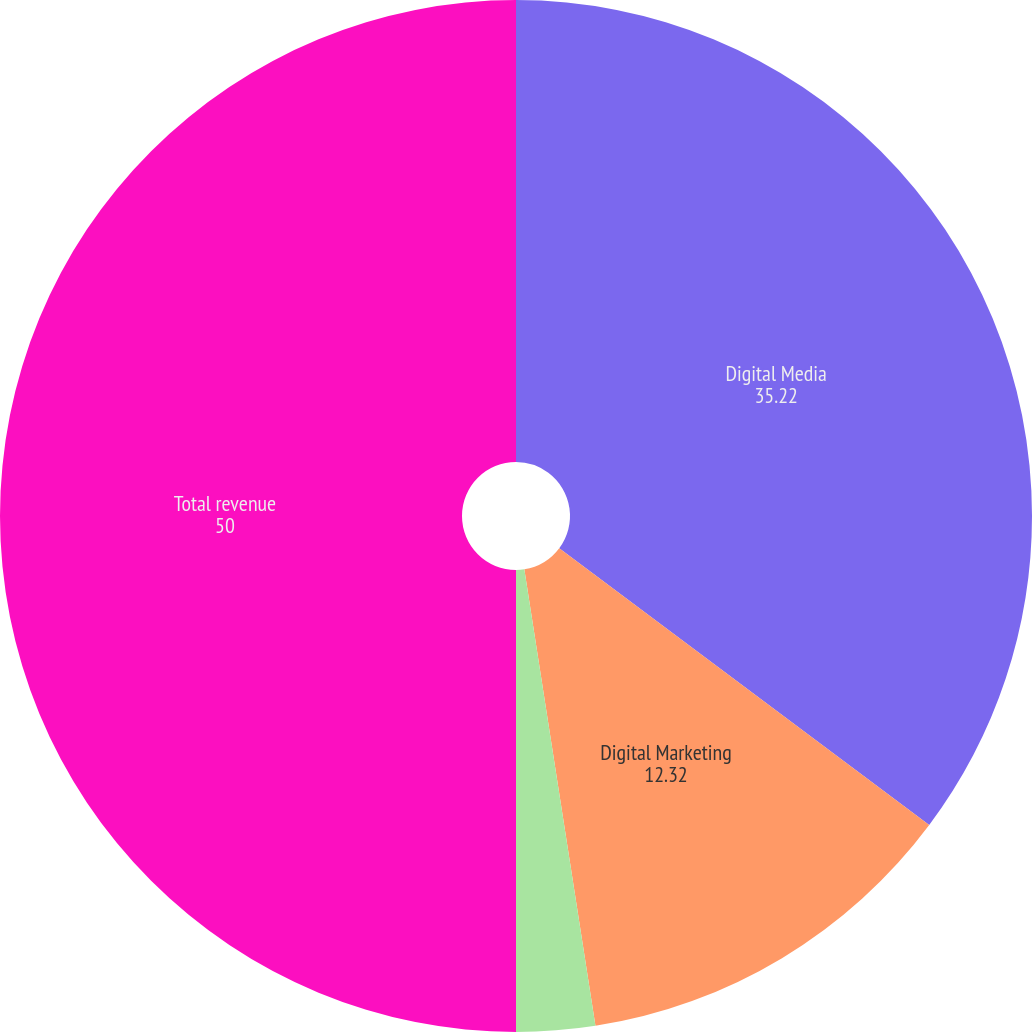Convert chart to OTSL. <chart><loc_0><loc_0><loc_500><loc_500><pie_chart><fcel>Digital Media<fcel>Digital Marketing<fcel>Print and Publishing<fcel>Total revenue<nl><fcel>35.22%<fcel>12.32%<fcel>2.46%<fcel>50.0%<nl></chart> 